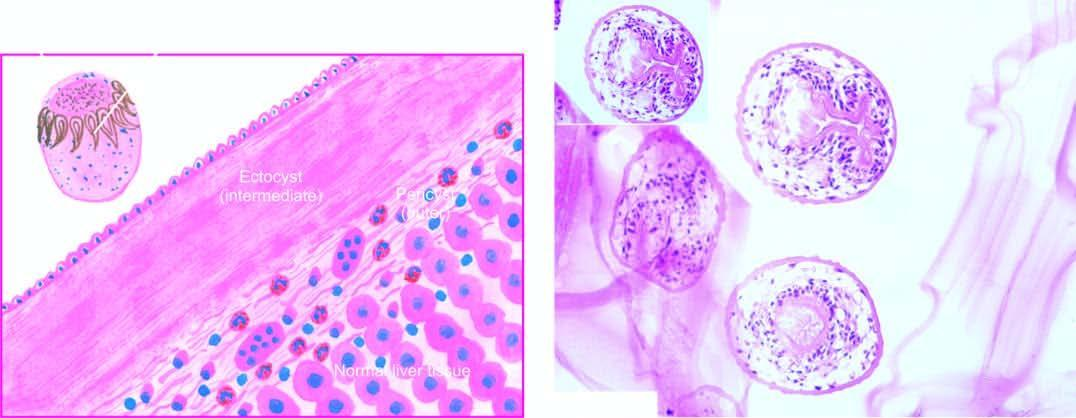does the peripheral zone show a scolex with a row of hooklets?
Answer the question using a single word or phrase. No 